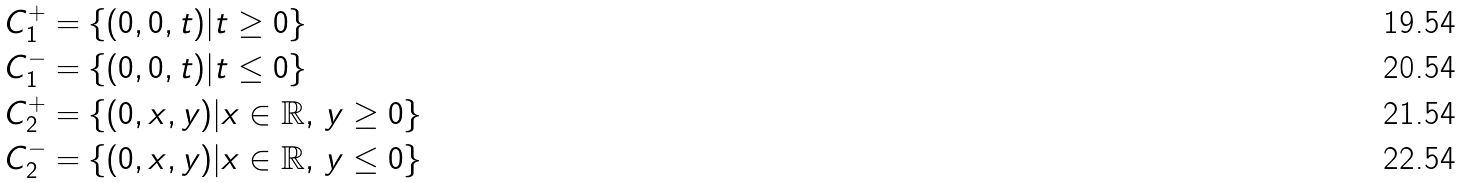<formula> <loc_0><loc_0><loc_500><loc_500>C _ { 1 } ^ { + } & = \left \{ ( 0 , 0 , t ) | t \geq 0 \right \} \\ C _ { 1 } ^ { - } & = \left \{ ( 0 , 0 , t ) | t \leq 0 \right \} \\ C _ { 2 } ^ { + } & = \left \{ ( 0 , x , y ) | x \in \mathbb { R } , \, y \geq 0 \right \} \\ C _ { 2 } ^ { - } & = \left \{ ( 0 , x , y ) | x \in \mathbb { R } , \, y \leq 0 \right \}</formula> 